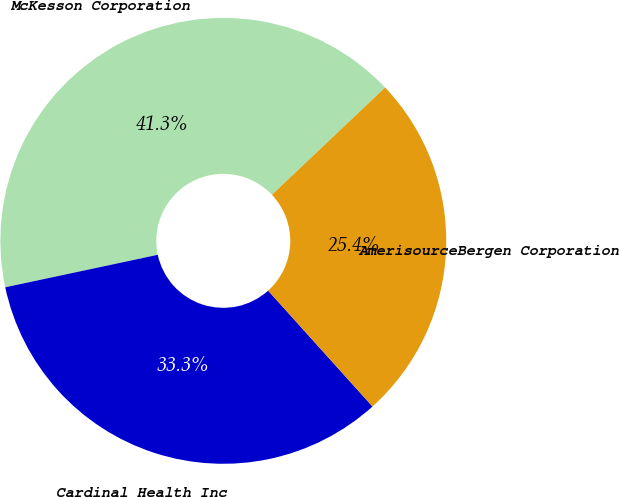Convert chart to OTSL. <chart><loc_0><loc_0><loc_500><loc_500><pie_chart><fcel>McKesson Corporation<fcel>Cardinal Health Inc<fcel>AmerisourceBergen Corporation<nl><fcel>41.27%<fcel>33.33%<fcel>25.4%<nl></chart> 